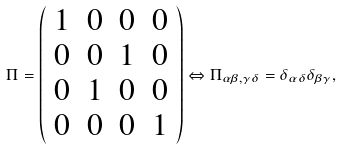<formula> <loc_0><loc_0><loc_500><loc_500>\Pi = \left ( \begin{array} { c c c c } 1 & 0 & 0 & 0 \\ 0 & 0 & 1 & 0 \\ 0 & 1 & 0 & 0 \\ 0 & 0 & 0 & 1 \end{array} \right ) \Leftrightarrow \Pi _ { \alpha \beta , \gamma \delta } = \delta _ { \alpha \delta } \delta _ { \beta \gamma } ,</formula> 